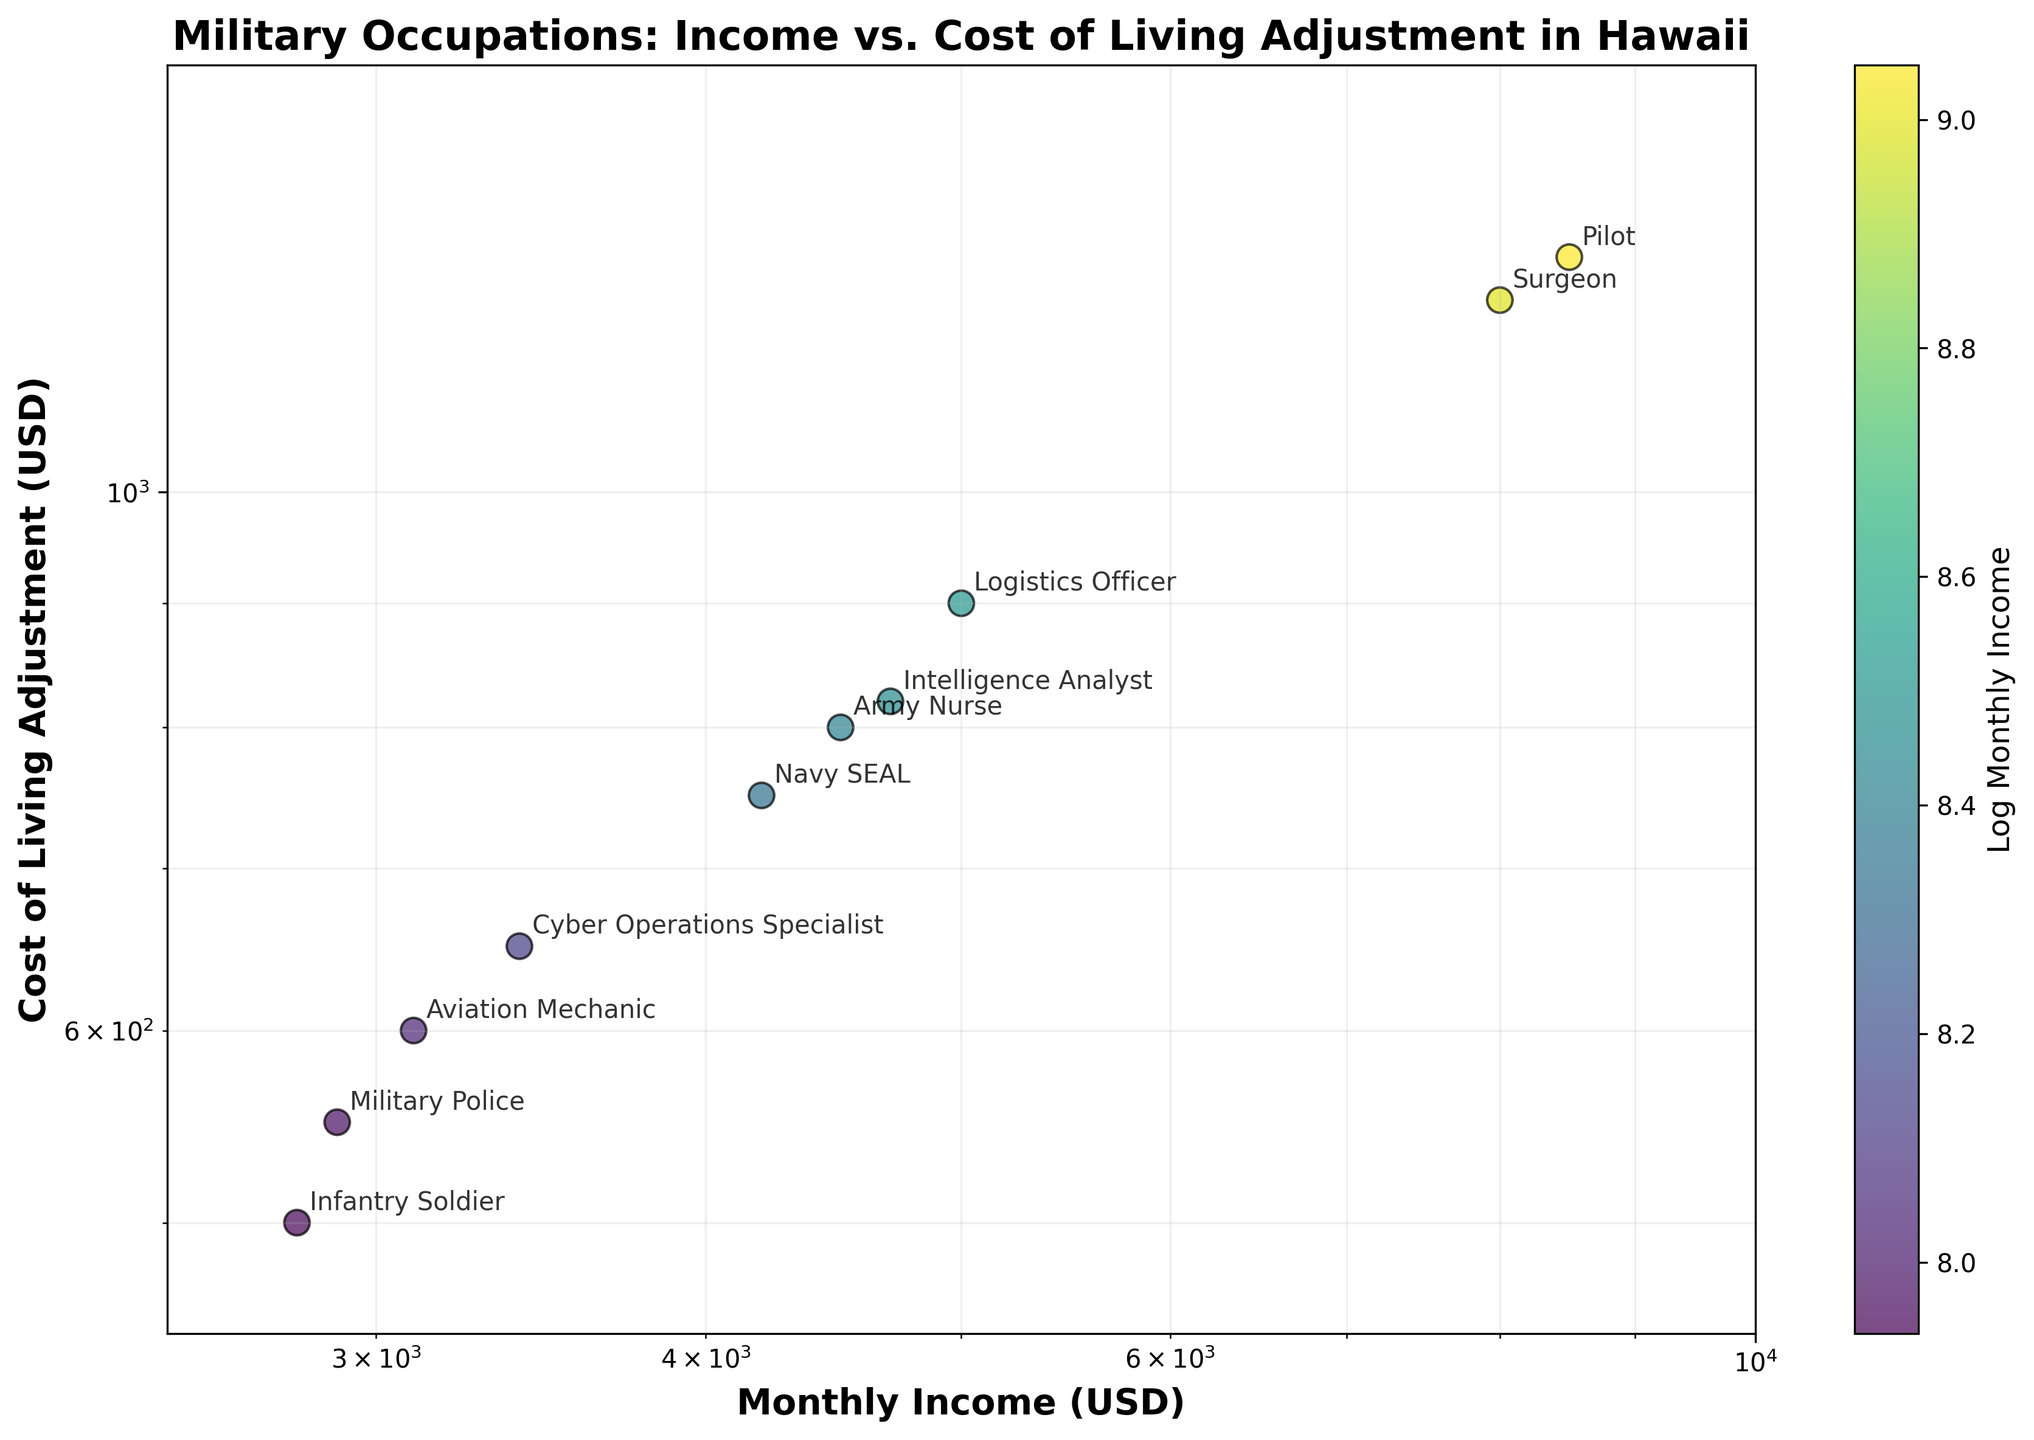What is the title of the figure? The title can be seen above the scatter plot and it provides a summary of what the figure is representing. In this case, it is written at the top center of the figure.
Answer: Military Occupations: Income vs. Cost of Living Adjustment in Hawaii On which axis is the Monthly Income plotted? Examine the labels beside the horizontal and vertical axes to see where the Monthly Income is positioned. The axis label indicates what is being measured.
Answer: X-axis What is the highest Monthly Income (USD) shown in the scatter plot? Look for the rightmost data point on the X-axis and identify its Monthly Income value. The point furthest to the right represents the highest Monthly Income.
Answer: 8500 Which occupation has the highest Cost of Living Adjustment (USD) in Hawaii? Identify the data point placed the highest along the Y-axis on the scatter plot, then refer to the annotations to find the corresponding occupation.
Answer: Pilot How many occupations have a Cost of Living Adjustment above 800 USD? Count the number of data points that lie above the 800 USD mark on the Y-axis.
Answer: 4 Which two occupations are closest in both Monthly Income and Cost of Living Adjustment? Look for two data points that are close to each other both horizontally and vertically. Compare their coordinates to determine the closest pairs.
Answer: Intelligence Analyst and Army Nurse Which occupation has a lower Monthly Income but a relatively high Cost of Living Adjustment? Find an occupation positioned on the left side of the X-axis but higher up on the Y-axis compared to other nearby data points. This indicates lower income but high living cost adjustments.
Answer: Cyber Operations Specialist What range does the X-axis cover on this scatter plot? Observe the scale markers on the X-axis to see the minimum and maximum values depicted.
Answer: 2500 to 10000 What is the color representing the highest Monthly Income in the scatter plot? Refer to the color bar legend to identify the color corresponding to the highest log scale value of Monthly Income.
Answer: Bright Yellow 